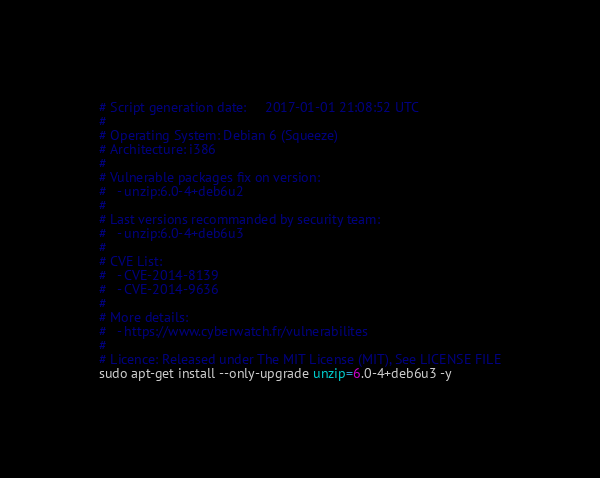Convert code to text. <code><loc_0><loc_0><loc_500><loc_500><_Bash_># Script generation date:     2017-01-01 21:08:52 UTC
#
# Operating System: Debian 6 (Squeeze)
# Architecture: i386
#
# Vulnerable packages fix on version:
#   - unzip:6.0-4+deb6u2
#
# Last versions recommanded by security team:
#   - unzip:6.0-4+deb6u3
#
# CVE List:
#   - CVE-2014-8139
#   - CVE-2014-9636
#
# More details:
#   - https://www.cyberwatch.fr/vulnerabilites
#
# Licence: Released under The MIT License (MIT), See LICENSE FILE
sudo apt-get install --only-upgrade unzip=6.0-4+deb6u3 -y
</code> 